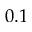<formula> <loc_0><loc_0><loc_500><loc_500>0 . 1</formula> 